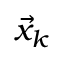<formula> <loc_0><loc_0><loc_500><loc_500>\vec { x } _ { k }</formula> 